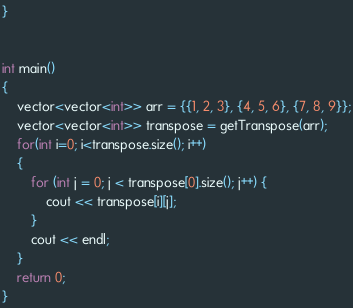<code> <loc_0><loc_0><loc_500><loc_500><_C++_>
}


int main()
{
    vector<vector<int>> arr = {{1, 2, 3}, {4, 5, 6}, {7, 8, 9}};
    vector<vector<int>> transpose = getTranspose(arr);
    for(int i=0; i<transpose.size(); i++)
    {
        for (int j = 0; j < transpose[0].size(); j++) {
            cout << transpose[i][j];
        }
        cout << endl;
    }
    return 0;
}</code> 